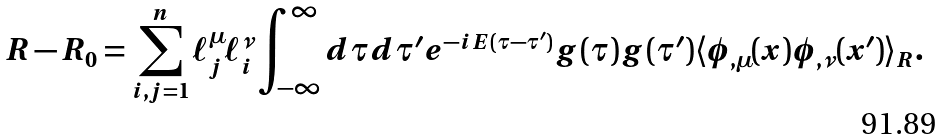<formula> <loc_0><loc_0><loc_500><loc_500>R - R _ { 0 } = \sum _ { i , j = 1 } ^ { n } { \ell _ { j } ^ { \mu } } { \ell _ { i } ^ { \nu } } \int _ { - \infty } ^ { \infty } d \tau d \tau ^ { \prime } e ^ { - i E ( \tau - \tau ^ { \prime } ) } g ( \tau ) g ( \tau ^ { \prime } ) \langle \phi _ { , \mu } ( x ) \phi _ { , \nu } ( x ^ { \prime } ) \rangle _ { R } .</formula> 